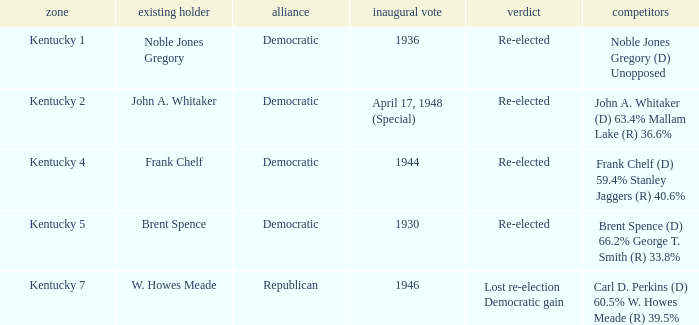What was the result of the election incumbent Brent Spence took place in? Re-elected. Parse the full table. {'header': ['zone', 'existing holder', 'alliance', 'inaugural vote', 'verdict', 'competitors'], 'rows': [['Kentucky 1', 'Noble Jones Gregory', 'Democratic', '1936', 'Re-elected', 'Noble Jones Gregory (D) Unopposed'], ['Kentucky 2', 'John A. Whitaker', 'Democratic', 'April 17, 1948 (Special)', 'Re-elected', 'John A. Whitaker (D) 63.4% Mallam Lake (R) 36.6%'], ['Kentucky 4', 'Frank Chelf', 'Democratic', '1944', 'Re-elected', 'Frank Chelf (D) 59.4% Stanley Jaggers (R) 40.6%'], ['Kentucky 5', 'Brent Spence', 'Democratic', '1930', 'Re-elected', 'Brent Spence (D) 66.2% George T. Smith (R) 33.8%'], ['Kentucky 7', 'W. Howes Meade', 'Republican', '1946', 'Lost re-election Democratic gain', 'Carl D. Perkins (D) 60.5% W. Howes Meade (R) 39.5%']]} 